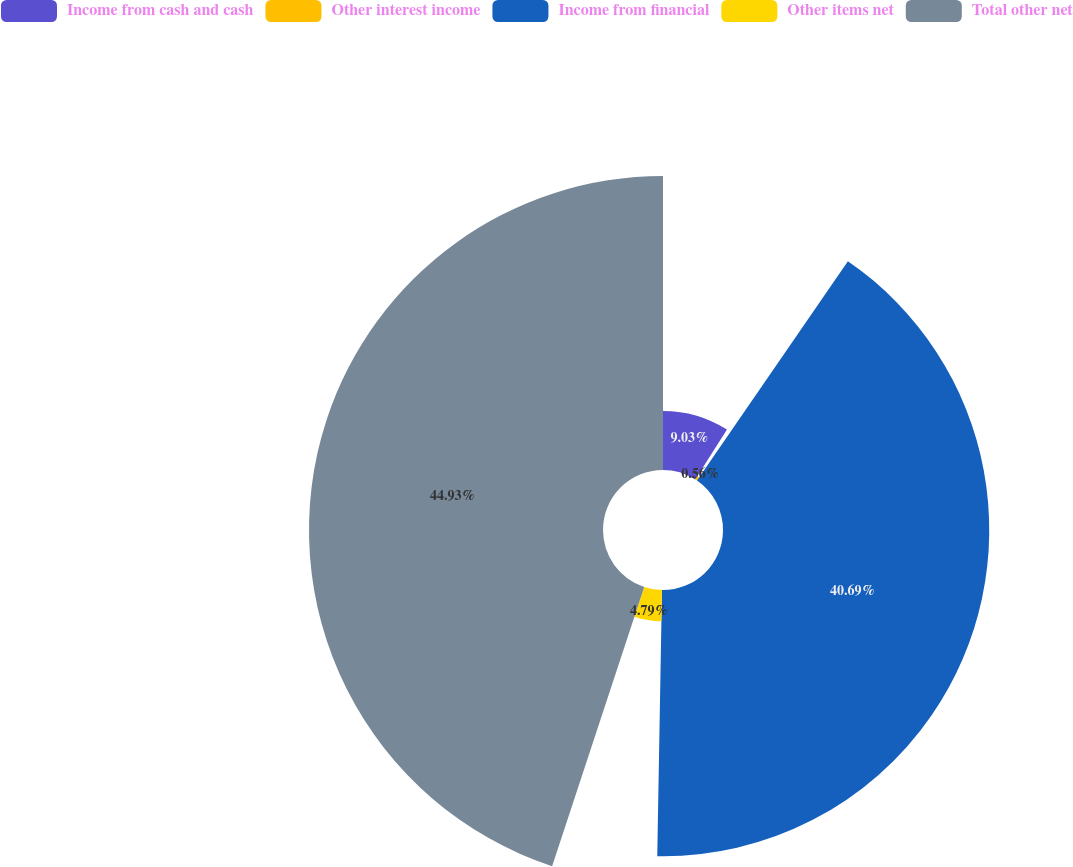<chart> <loc_0><loc_0><loc_500><loc_500><pie_chart><fcel>Income from cash and cash<fcel>Other interest income<fcel>Income from financial<fcel>Other items net<fcel>Total other net<nl><fcel>9.03%<fcel>0.56%<fcel>40.69%<fcel>4.79%<fcel>44.93%<nl></chart> 